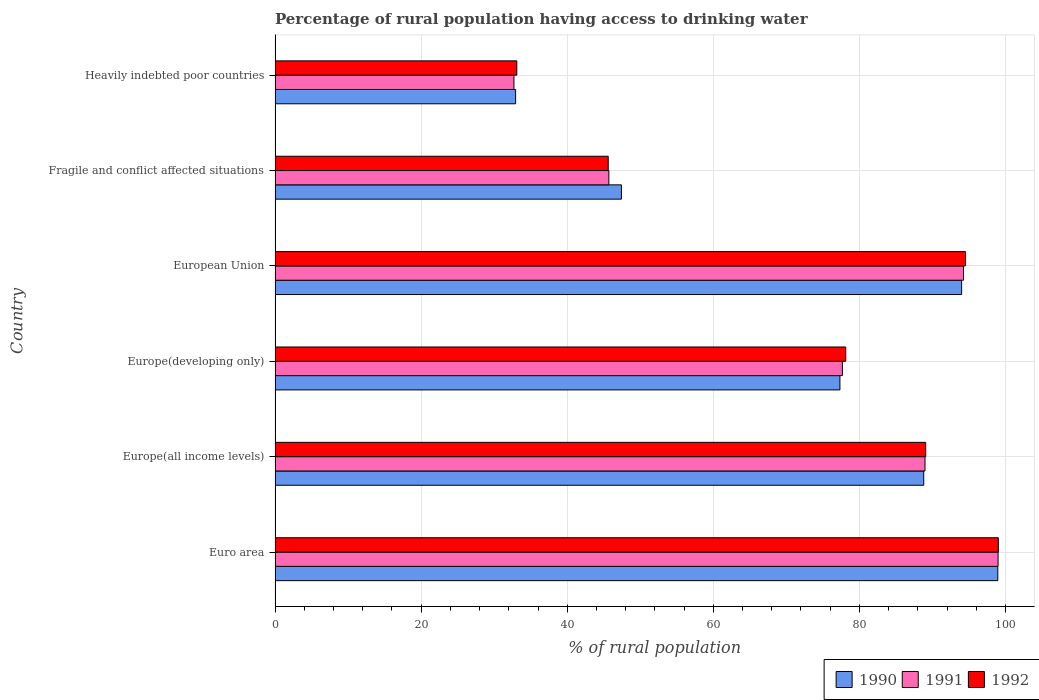How many different coloured bars are there?
Your response must be concise. 3. How many groups of bars are there?
Your answer should be very brief. 6. Are the number of bars on each tick of the Y-axis equal?
Provide a short and direct response. Yes. How many bars are there on the 2nd tick from the top?
Give a very brief answer. 3. What is the label of the 4th group of bars from the top?
Offer a very short reply. Europe(developing only). What is the percentage of rural population having access to drinking water in 1991 in Europe(developing only)?
Provide a short and direct response. 77.67. Across all countries, what is the maximum percentage of rural population having access to drinking water in 1990?
Provide a succinct answer. 98.95. Across all countries, what is the minimum percentage of rural population having access to drinking water in 1991?
Offer a terse response. 32.7. In which country was the percentage of rural population having access to drinking water in 1990 minimum?
Your answer should be compact. Heavily indebted poor countries. What is the total percentage of rural population having access to drinking water in 1991 in the graph?
Offer a terse response. 438.29. What is the difference between the percentage of rural population having access to drinking water in 1992 in Euro area and that in Europe(all income levels)?
Provide a succinct answer. 9.95. What is the difference between the percentage of rural population having access to drinking water in 1992 in European Union and the percentage of rural population having access to drinking water in 1991 in Fragile and conflict affected situations?
Ensure brevity in your answer.  48.83. What is the average percentage of rural population having access to drinking water in 1992 per country?
Offer a terse response. 73.24. What is the difference between the percentage of rural population having access to drinking water in 1992 and percentage of rural population having access to drinking water in 1991 in European Union?
Provide a succinct answer. 0.27. What is the ratio of the percentage of rural population having access to drinking water in 1992 in Europe(all income levels) to that in European Union?
Your answer should be very brief. 0.94. Is the percentage of rural population having access to drinking water in 1990 in Europe(all income levels) less than that in Heavily indebted poor countries?
Keep it short and to the point. No. Is the difference between the percentage of rural population having access to drinking water in 1992 in Fragile and conflict affected situations and Heavily indebted poor countries greater than the difference between the percentage of rural population having access to drinking water in 1991 in Fragile and conflict affected situations and Heavily indebted poor countries?
Ensure brevity in your answer.  No. What is the difference between the highest and the second highest percentage of rural population having access to drinking water in 1990?
Offer a terse response. 4.95. What is the difference between the highest and the lowest percentage of rural population having access to drinking water in 1992?
Ensure brevity in your answer.  65.93. Is the sum of the percentage of rural population having access to drinking water in 1991 in Europe(all income levels) and European Union greater than the maximum percentage of rural population having access to drinking water in 1992 across all countries?
Offer a terse response. Yes. What does the 3rd bar from the bottom in European Union represents?
Provide a succinct answer. 1992. Is it the case that in every country, the sum of the percentage of rural population having access to drinking water in 1990 and percentage of rural population having access to drinking water in 1991 is greater than the percentage of rural population having access to drinking water in 1992?
Offer a terse response. Yes. How many countries are there in the graph?
Your answer should be very brief. 6. Does the graph contain grids?
Provide a short and direct response. Yes. Where does the legend appear in the graph?
Your answer should be very brief. Bottom right. How are the legend labels stacked?
Offer a very short reply. Horizontal. What is the title of the graph?
Provide a succinct answer. Percentage of rural population having access to drinking water. What is the label or title of the X-axis?
Your answer should be compact. % of rural population. What is the % of rural population in 1990 in Euro area?
Give a very brief answer. 98.95. What is the % of rural population of 1991 in Euro area?
Give a very brief answer. 98.99. What is the % of rural population in 1992 in Euro area?
Provide a succinct answer. 99.02. What is the % of rural population in 1990 in Europe(all income levels)?
Provide a succinct answer. 88.81. What is the % of rural population of 1991 in Europe(all income levels)?
Provide a succinct answer. 88.98. What is the % of rural population in 1992 in Europe(all income levels)?
Your response must be concise. 89.07. What is the % of rural population of 1990 in Europe(developing only)?
Offer a very short reply. 77.33. What is the % of rural population of 1991 in Europe(developing only)?
Ensure brevity in your answer.  77.67. What is the % of rural population in 1992 in Europe(developing only)?
Provide a short and direct response. 78.13. What is the % of rural population of 1990 in European Union?
Give a very brief answer. 93.99. What is the % of rural population in 1991 in European Union?
Your response must be concise. 94.25. What is the % of rural population of 1992 in European Union?
Offer a terse response. 94.53. What is the % of rural population in 1990 in Fragile and conflict affected situations?
Offer a very short reply. 47.42. What is the % of rural population in 1991 in Fragile and conflict affected situations?
Offer a very short reply. 45.7. What is the % of rural population of 1992 in Fragile and conflict affected situations?
Keep it short and to the point. 45.61. What is the % of rural population in 1990 in Heavily indebted poor countries?
Give a very brief answer. 32.93. What is the % of rural population in 1991 in Heavily indebted poor countries?
Offer a very short reply. 32.7. What is the % of rural population in 1992 in Heavily indebted poor countries?
Give a very brief answer. 33.09. Across all countries, what is the maximum % of rural population in 1990?
Offer a very short reply. 98.95. Across all countries, what is the maximum % of rural population in 1991?
Your answer should be very brief. 98.99. Across all countries, what is the maximum % of rural population of 1992?
Your answer should be very brief. 99.02. Across all countries, what is the minimum % of rural population in 1990?
Your answer should be very brief. 32.93. Across all countries, what is the minimum % of rural population of 1991?
Offer a terse response. 32.7. Across all countries, what is the minimum % of rural population of 1992?
Give a very brief answer. 33.09. What is the total % of rural population in 1990 in the graph?
Provide a succinct answer. 439.43. What is the total % of rural population of 1991 in the graph?
Your answer should be very brief. 438.29. What is the total % of rural population in 1992 in the graph?
Offer a very short reply. 439.46. What is the difference between the % of rural population in 1990 in Euro area and that in Europe(all income levels)?
Give a very brief answer. 10.14. What is the difference between the % of rural population of 1991 in Euro area and that in Europe(all income levels)?
Offer a very short reply. 10.01. What is the difference between the % of rural population of 1992 in Euro area and that in Europe(all income levels)?
Offer a terse response. 9.95. What is the difference between the % of rural population of 1990 in Euro area and that in Europe(developing only)?
Keep it short and to the point. 21.62. What is the difference between the % of rural population of 1991 in Euro area and that in Europe(developing only)?
Provide a short and direct response. 21.32. What is the difference between the % of rural population of 1992 in Euro area and that in Europe(developing only)?
Give a very brief answer. 20.89. What is the difference between the % of rural population in 1990 in Euro area and that in European Union?
Your answer should be very brief. 4.95. What is the difference between the % of rural population of 1991 in Euro area and that in European Union?
Provide a short and direct response. 4.73. What is the difference between the % of rural population of 1992 in Euro area and that in European Union?
Provide a succinct answer. 4.49. What is the difference between the % of rural population of 1990 in Euro area and that in Fragile and conflict affected situations?
Give a very brief answer. 51.53. What is the difference between the % of rural population in 1991 in Euro area and that in Fragile and conflict affected situations?
Provide a short and direct response. 53.29. What is the difference between the % of rural population of 1992 in Euro area and that in Fragile and conflict affected situations?
Your response must be concise. 53.41. What is the difference between the % of rural population in 1990 in Euro area and that in Heavily indebted poor countries?
Your response must be concise. 66.02. What is the difference between the % of rural population in 1991 in Euro area and that in Heavily indebted poor countries?
Provide a short and direct response. 66.28. What is the difference between the % of rural population of 1992 in Euro area and that in Heavily indebted poor countries?
Provide a short and direct response. 65.93. What is the difference between the % of rural population in 1990 in Europe(all income levels) and that in Europe(developing only)?
Offer a terse response. 11.48. What is the difference between the % of rural population in 1991 in Europe(all income levels) and that in Europe(developing only)?
Keep it short and to the point. 11.31. What is the difference between the % of rural population of 1992 in Europe(all income levels) and that in Europe(developing only)?
Offer a very short reply. 10.94. What is the difference between the % of rural population of 1990 in Europe(all income levels) and that in European Union?
Offer a terse response. -5.19. What is the difference between the % of rural population in 1991 in Europe(all income levels) and that in European Union?
Your response must be concise. -5.27. What is the difference between the % of rural population in 1992 in Europe(all income levels) and that in European Union?
Give a very brief answer. -5.45. What is the difference between the % of rural population in 1990 in Europe(all income levels) and that in Fragile and conflict affected situations?
Provide a succinct answer. 41.39. What is the difference between the % of rural population in 1991 in Europe(all income levels) and that in Fragile and conflict affected situations?
Give a very brief answer. 43.28. What is the difference between the % of rural population of 1992 in Europe(all income levels) and that in Fragile and conflict affected situations?
Provide a short and direct response. 43.46. What is the difference between the % of rural population in 1990 in Europe(all income levels) and that in Heavily indebted poor countries?
Ensure brevity in your answer.  55.88. What is the difference between the % of rural population of 1991 in Europe(all income levels) and that in Heavily indebted poor countries?
Offer a very short reply. 56.28. What is the difference between the % of rural population in 1992 in Europe(all income levels) and that in Heavily indebted poor countries?
Keep it short and to the point. 55.98. What is the difference between the % of rural population in 1990 in Europe(developing only) and that in European Union?
Your answer should be compact. -16.66. What is the difference between the % of rural population of 1991 in Europe(developing only) and that in European Union?
Your response must be concise. -16.59. What is the difference between the % of rural population in 1992 in Europe(developing only) and that in European Union?
Offer a terse response. -16.4. What is the difference between the % of rural population of 1990 in Europe(developing only) and that in Fragile and conflict affected situations?
Provide a short and direct response. 29.91. What is the difference between the % of rural population of 1991 in Europe(developing only) and that in Fragile and conflict affected situations?
Your response must be concise. 31.97. What is the difference between the % of rural population in 1992 in Europe(developing only) and that in Fragile and conflict affected situations?
Make the answer very short. 32.52. What is the difference between the % of rural population in 1990 in Europe(developing only) and that in Heavily indebted poor countries?
Your response must be concise. 44.4. What is the difference between the % of rural population in 1991 in Europe(developing only) and that in Heavily indebted poor countries?
Offer a very short reply. 44.97. What is the difference between the % of rural population in 1992 in Europe(developing only) and that in Heavily indebted poor countries?
Make the answer very short. 45.04. What is the difference between the % of rural population of 1990 in European Union and that in Fragile and conflict affected situations?
Your response must be concise. 46.57. What is the difference between the % of rural population in 1991 in European Union and that in Fragile and conflict affected situations?
Give a very brief answer. 48.56. What is the difference between the % of rural population in 1992 in European Union and that in Fragile and conflict affected situations?
Your response must be concise. 48.92. What is the difference between the % of rural population of 1990 in European Union and that in Heavily indebted poor countries?
Your answer should be very brief. 61.06. What is the difference between the % of rural population in 1991 in European Union and that in Heavily indebted poor countries?
Provide a succinct answer. 61.55. What is the difference between the % of rural population in 1992 in European Union and that in Heavily indebted poor countries?
Make the answer very short. 61.43. What is the difference between the % of rural population in 1990 in Fragile and conflict affected situations and that in Heavily indebted poor countries?
Offer a terse response. 14.49. What is the difference between the % of rural population in 1991 in Fragile and conflict affected situations and that in Heavily indebted poor countries?
Give a very brief answer. 12.99. What is the difference between the % of rural population of 1992 in Fragile and conflict affected situations and that in Heavily indebted poor countries?
Your answer should be very brief. 12.52. What is the difference between the % of rural population in 1990 in Euro area and the % of rural population in 1991 in Europe(all income levels)?
Your answer should be compact. 9.97. What is the difference between the % of rural population of 1990 in Euro area and the % of rural population of 1992 in Europe(all income levels)?
Provide a short and direct response. 9.87. What is the difference between the % of rural population in 1991 in Euro area and the % of rural population in 1992 in Europe(all income levels)?
Ensure brevity in your answer.  9.91. What is the difference between the % of rural population in 1990 in Euro area and the % of rural population in 1991 in Europe(developing only)?
Your response must be concise. 21.28. What is the difference between the % of rural population in 1990 in Euro area and the % of rural population in 1992 in Europe(developing only)?
Offer a very short reply. 20.82. What is the difference between the % of rural population in 1991 in Euro area and the % of rural population in 1992 in Europe(developing only)?
Your response must be concise. 20.85. What is the difference between the % of rural population in 1990 in Euro area and the % of rural population in 1991 in European Union?
Keep it short and to the point. 4.69. What is the difference between the % of rural population in 1990 in Euro area and the % of rural population in 1992 in European Union?
Provide a succinct answer. 4.42. What is the difference between the % of rural population in 1991 in Euro area and the % of rural population in 1992 in European Union?
Your answer should be compact. 4.46. What is the difference between the % of rural population of 1990 in Euro area and the % of rural population of 1991 in Fragile and conflict affected situations?
Make the answer very short. 53.25. What is the difference between the % of rural population of 1990 in Euro area and the % of rural population of 1992 in Fragile and conflict affected situations?
Your answer should be compact. 53.34. What is the difference between the % of rural population of 1991 in Euro area and the % of rural population of 1992 in Fragile and conflict affected situations?
Give a very brief answer. 53.37. What is the difference between the % of rural population of 1990 in Euro area and the % of rural population of 1991 in Heavily indebted poor countries?
Your response must be concise. 66.24. What is the difference between the % of rural population of 1990 in Euro area and the % of rural population of 1992 in Heavily indebted poor countries?
Your answer should be compact. 65.85. What is the difference between the % of rural population of 1991 in Euro area and the % of rural population of 1992 in Heavily indebted poor countries?
Your answer should be very brief. 65.89. What is the difference between the % of rural population of 1990 in Europe(all income levels) and the % of rural population of 1991 in Europe(developing only)?
Offer a very short reply. 11.14. What is the difference between the % of rural population of 1990 in Europe(all income levels) and the % of rural population of 1992 in Europe(developing only)?
Your answer should be compact. 10.68. What is the difference between the % of rural population in 1991 in Europe(all income levels) and the % of rural population in 1992 in Europe(developing only)?
Give a very brief answer. 10.85. What is the difference between the % of rural population of 1990 in Europe(all income levels) and the % of rural population of 1991 in European Union?
Provide a succinct answer. -5.45. What is the difference between the % of rural population in 1990 in Europe(all income levels) and the % of rural population in 1992 in European Union?
Your response must be concise. -5.72. What is the difference between the % of rural population of 1991 in Europe(all income levels) and the % of rural population of 1992 in European Union?
Your answer should be very brief. -5.55. What is the difference between the % of rural population in 1990 in Europe(all income levels) and the % of rural population in 1991 in Fragile and conflict affected situations?
Your answer should be compact. 43.11. What is the difference between the % of rural population of 1990 in Europe(all income levels) and the % of rural population of 1992 in Fragile and conflict affected situations?
Offer a terse response. 43.2. What is the difference between the % of rural population of 1991 in Europe(all income levels) and the % of rural population of 1992 in Fragile and conflict affected situations?
Offer a terse response. 43.37. What is the difference between the % of rural population in 1990 in Europe(all income levels) and the % of rural population in 1991 in Heavily indebted poor countries?
Your answer should be very brief. 56.11. What is the difference between the % of rural population in 1990 in Europe(all income levels) and the % of rural population in 1992 in Heavily indebted poor countries?
Your answer should be compact. 55.71. What is the difference between the % of rural population in 1991 in Europe(all income levels) and the % of rural population in 1992 in Heavily indebted poor countries?
Provide a short and direct response. 55.89. What is the difference between the % of rural population in 1990 in Europe(developing only) and the % of rural population in 1991 in European Union?
Your response must be concise. -16.92. What is the difference between the % of rural population in 1990 in Europe(developing only) and the % of rural population in 1992 in European Union?
Make the answer very short. -17.19. What is the difference between the % of rural population of 1991 in Europe(developing only) and the % of rural population of 1992 in European Union?
Your answer should be compact. -16.86. What is the difference between the % of rural population in 1990 in Europe(developing only) and the % of rural population in 1991 in Fragile and conflict affected situations?
Provide a short and direct response. 31.64. What is the difference between the % of rural population in 1990 in Europe(developing only) and the % of rural population in 1992 in Fragile and conflict affected situations?
Keep it short and to the point. 31.72. What is the difference between the % of rural population in 1991 in Europe(developing only) and the % of rural population in 1992 in Fragile and conflict affected situations?
Your answer should be compact. 32.06. What is the difference between the % of rural population of 1990 in Europe(developing only) and the % of rural population of 1991 in Heavily indebted poor countries?
Offer a very short reply. 44.63. What is the difference between the % of rural population in 1990 in Europe(developing only) and the % of rural population in 1992 in Heavily indebted poor countries?
Ensure brevity in your answer.  44.24. What is the difference between the % of rural population in 1991 in Europe(developing only) and the % of rural population in 1992 in Heavily indebted poor countries?
Provide a short and direct response. 44.57. What is the difference between the % of rural population in 1990 in European Union and the % of rural population in 1991 in Fragile and conflict affected situations?
Offer a terse response. 48.3. What is the difference between the % of rural population in 1990 in European Union and the % of rural population in 1992 in Fragile and conflict affected situations?
Provide a short and direct response. 48.38. What is the difference between the % of rural population of 1991 in European Union and the % of rural population of 1992 in Fragile and conflict affected situations?
Provide a short and direct response. 48.64. What is the difference between the % of rural population of 1990 in European Union and the % of rural population of 1991 in Heavily indebted poor countries?
Your answer should be very brief. 61.29. What is the difference between the % of rural population in 1990 in European Union and the % of rural population in 1992 in Heavily indebted poor countries?
Ensure brevity in your answer.  60.9. What is the difference between the % of rural population of 1991 in European Union and the % of rural population of 1992 in Heavily indebted poor countries?
Make the answer very short. 61.16. What is the difference between the % of rural population of 1990 in Fragile and conflict affected situations and the % of rural population of 1991 in Heavily indebted poor countries?
Provide a succinct answer. 14.72. What is the difference between the % of rural population of 1990 in Fragile and conflict affected situations and the % of rural population of 1992 in Heavily indebted poor countries?
Give a very brief answer. 14.33. What is the difference between the % of rural population in 1991 in Fragile and conflict affected situations and the % of rural population in 1992 in Heavily indebted poor countries?
Your answer should be very brief. 12.6. What is the average % of rural population in 1990 per country?
Provide a short and direct response. 73.24. What is the average % of rural population of 1991 per country?
Provide a short and direct response. 73.05. What is the average % of rural population in 1992 per country?
Your answer should be compact. 73.24. What is the difference between the % of rural population of 1990 and % of rural population of 1991 in Euro area?
Keep it short and to the point. -0.04. What is the difference between the % of rural population in 1990 and % of rural population in 1992 in Euro area?
Offer a very short reply. -0.07. What is the difference between the % of rural population in 1991 and % of rural population in 1992 in Euro area?
Keep it short and to the point. -0.04. What is the difference between the % of rural population of 1990 and % of rural population of 1991 in Europe(all income levels)?
Keep it short and to the point. -0.17. What is the difference between the % of rural population in 1990 and % of rural population in 1992 in Europe(all income levels)?
Your answer should be compact. -0.27. What is the difference between the % of rural population of 1991 and % of rural population of 1992 in Europe(all income levels)?
Your answer should be compact. -0.09. What is the difference between the % of rural population of 1990 and % of rural population of 1991 in Europe(developing only)?
Make the answer very short. -0.34. What is the difference between the % of rural population of 1990 and % of rural population of 1992 in Europe(developing only)?
Your answer should be compact. -0.8. What is the difference between the % of rural population of 1991 and % of rural population of 1992 in Europe(developing only)?
Make the answer very short. -0.46. What is the difference between the % of rural population in 1990 and % of rural population in 1991 in European Union?
Your response must be concise. -0.26. What is the difference between the % of rural population in 1990 and % of rural population in 1992 in European Union?
Your answer should be compact. -0.53. What is the difference between the % of rural population in 1991 and % of rural population in 1992 in European Union?
Offer a terse response. -0.27. What is the difference between the % of rural population in 1990 and % of rural population in 1991 in Fragile and conflict affected situations?
Offer a terse response. 1.72. What is the difference between the % of rural population of 1990 and % of rural population of 1992 in Fragile and conflict affected situations?
Provide a short and direct response. 1.81. What is the difference between the % of rural population in 1991 and % of rural population in 1992 in Fragile and conflict affected situations?
Give a very brief answer. 0.09. What is the difference between the % of rural population in 1990 and % of rural population in 1991 in Heavily indebted poor countries?
Make the answer very short. 0.23. What is the difference between the % of rural population in 1990 and % of rural population in 1992 in Heavily indebted poor countries?
Give a very brief answer. -0.16. What is the difference between the % of rural population of 1991 and % of rural population of 1992 in Heavily indebted poor countries?
Offer a terse response. -0.39. What is the ratio of the % of rural population of 1990 in Euro area to that in Europe(all income levels)?
Provide a succinct answer. 1.11. What is the ratio of the % of rural population of 1991 in Euro area to that in Europe(all income levels)?
Ensure brevity in your answer.  1.11. What is the ratio of the % of rural population of 1992 in Euro area to that in Europe(all income levels)?
Provide a short and direct response. 1.11. What is the ratio of the % of rural population of 1990 in Euro area to that in Europe(developing only)?
Provide a short and direct response. 1.28. What is the ratio of the % of rural population in 1991 in Euro area to that in Europe(developing only)?
Ensure brevity in your answer.  1.27. What is the ratio of the % of rural population in 1992 in Euro area to that in Europe(developing only)?
Your answer should be compact. 1.27. What is the ratio of the % of rural population of 1990 in Euro area to that in European Union?
Give a very brief answer. 1.05. What is the ratio of the % of rural population in 1991 in Euro area to that in European Union?
Your response must be concise. 1.05. What is the ratio of the % of rural population in 1992 in Euro area to that in European Union?
Your answer should be very brief. 1.05. What is the ratio of the % of rural population of 1990 in Euro area to that in Fragile and conflict affected situations?
Offer a very short reply. 2.09. What is the ratio of the % of rural population in 1991 in Euro area to that in Fragile and conflict affected situations?
Your response must be concise. 2.17. What is the ratio of the % of rural population of 1992 in Euro area to that in Fragile and conflict affected situations?
Ensure brevity in your answer.  2.17. What is the ratio of the % of rural population of 1990 in Euro area to that in Heavily indebted poor countries?
Your response must be concise. 3. What is the ratio of the % of rural population in 1991 in Euro area to that in Heavily indebted poor countries?
Offer a terse response. 3.03. What is the ratio of the % of rural population of 1992 in Euro area to that in Heavily indebted poor countries?
Provide a short and direct response. 2.99. What is the ratio of the % of rural population in 1990 in Europe(all income levels) to that in Europe(developing only)?
Make the answer very short. 1.15. What is the ratio of the % of rural population of 1991 in Europe(all income levels) to that in Europe(developing only)?
Make the answer very short. 1.15. What is the ratio of the % of rural population of 1992 in Europe(all income levels) to that in Europe(developing only)?
Your response must be concise. 1.14. What is the ratio of the % of rural population in 1990 in Europe(all income levels) to that in European Union?
Provide a succinct answer. 0.94. What is the ratio of the % of rural population in 1991 in Europe(all income levels) to that in European Union?
Your answer should be compact. 0.94. What is the ratio of the % of rural population in 1992 in Europe(all income levels) to that in European Union?
Offer a terse response. 0.94. What is the ratio of the % of rural population in 1990 in Europe(all income levels) to that in Fragile and conflict affected situations?
Make the answer very short. 1.87. What is the ratio of the % of rural population in 1991 in Europe(all income levels) to that in Fragile and conflict affected situations?
Provide a succinct answer. 1.95. What is the ratio of the % of rural population in 1992 in Europe(all income levels) to that in Fragile and conflict affected situations?
Your answer should be very brief. 1.95. What is the ratio of the % of rural population in 1990 in Europe(all income levels) to that in Heavily indebted poor countries?
Ensure brevity in your answer.  2.7. What is the ratio of the % of rural population of 1991 in Europe(all income levels) to that in Heavily indebted poor countries?
Provide a succinct answer. 2.72. What is the ratio of the % of rural population of 1992 in Europe(all income levels) to that in Heavily indebted poor countries?
Provide a succinct answer. 2.69. What is the ratio of the % of rural population in 1990 in Europe(developing only) to that in European Union?
Your response must be concise. 0.82. What is the ratio of the % of rural population in 1991 in Europe(developing only) to that in European Union?
Ensure brevity in your answer.  0.82. What is the ratio of the % of rural population of 1992 in Europe(developing only) to that in European Union?
Your answer should be very brief. 0.83. What is the ratio of the % of rural population of 1990 in Europe(developing only) to that in Fragile and conflict affected situations?
Give a very brief answer. 1.63. What is the ratio of the % of rural population in 1991 in Europe(developing only) to that in Fragile and conflict affected situations?
Your response must be concise. 1.7. What is the ratio of the % of rural population in 1992 in Europe(developing only) to that in Fragile and conflict affected situations?
Your response must be concise. 1.71. What is the ratio of the % of rural population of 1990 in Europe(developing only) to that in Heavily indebted poor countries?
Provide a succinct answer. 2.35. What is the ratio of the % of rural population in 1991 in Europe(developing only) to that in Heavily indebted poor countries?
Offer a very short reply. 2.38. What is the ratio of the % of rural population of 1992 in Europe(developing only) to that in Heavily indebted poor countries?
Your answer should be compact. 2.36. What is the ratio of the % of rural population of 1990 in European Union to that in Fragile and conflict affected situations?
Provide a succinct answer. 1.98. What is the ratio of the % of rural population of 1991 in European Union to that in Fragile and conflict affected situations?
Offer a terse response. 2.06. What is the ratio of the % of rural population of 1992 in European Union to that in Fragile and conflict affected situations?
Offer a terse response. 2.07. What is the ratio of the % of rural population of 1990 in European Union to that in Heavily indebted poor countries?
Ensure brevity in your answer.  2.85. What is the ratio of the % of rural population in 1991 in European Union to that in Heavily indebted poor countries?
Ensure brevity in your answer.  2.88. What is the ratio of the % of rural population in 1992 in European Union to that in Heavily indebted poor countries?
Give a very brief answer. 2.86. What is the ratio of the % of rural population in 1990 in Fragile and conflict affected situations to that in Heavily indebted poor countries?
Provide a short and direct response. 1.44. What is the ratio of the % of rural population in 1991 in Fragile and conflict affected situations to that in Heavily indebted poor countries?
Your answer should be compact. 1.4. What is the ratio of the % of rural population of 1992 in Fragile and conflict affected situations to that in Heavily indebted poor countries?
Give a very brief answer. 1.38. What is the difference between the highest and the second highest % of rural population in 1990?
Give a very brief answer. 4.95. What is the difference between the highest and the second highest % of rural population of 1991?
Make the answer very short. 4.73. What is the difference between the highest and the second highest % of rural population in 1992?
Ensure brevity in your answer.  4.49. What is the difference between the highest and the lowest % of rural population in 1990?
Your answer should be compact. 66.02. What is the difference between the highest and the lowest % of rural population of 1991?
Your answer should be compact. 66.28. What is the difference between the highest and the lowest % of rural population of 1992?
Keep it short and to the point. 65.93. 